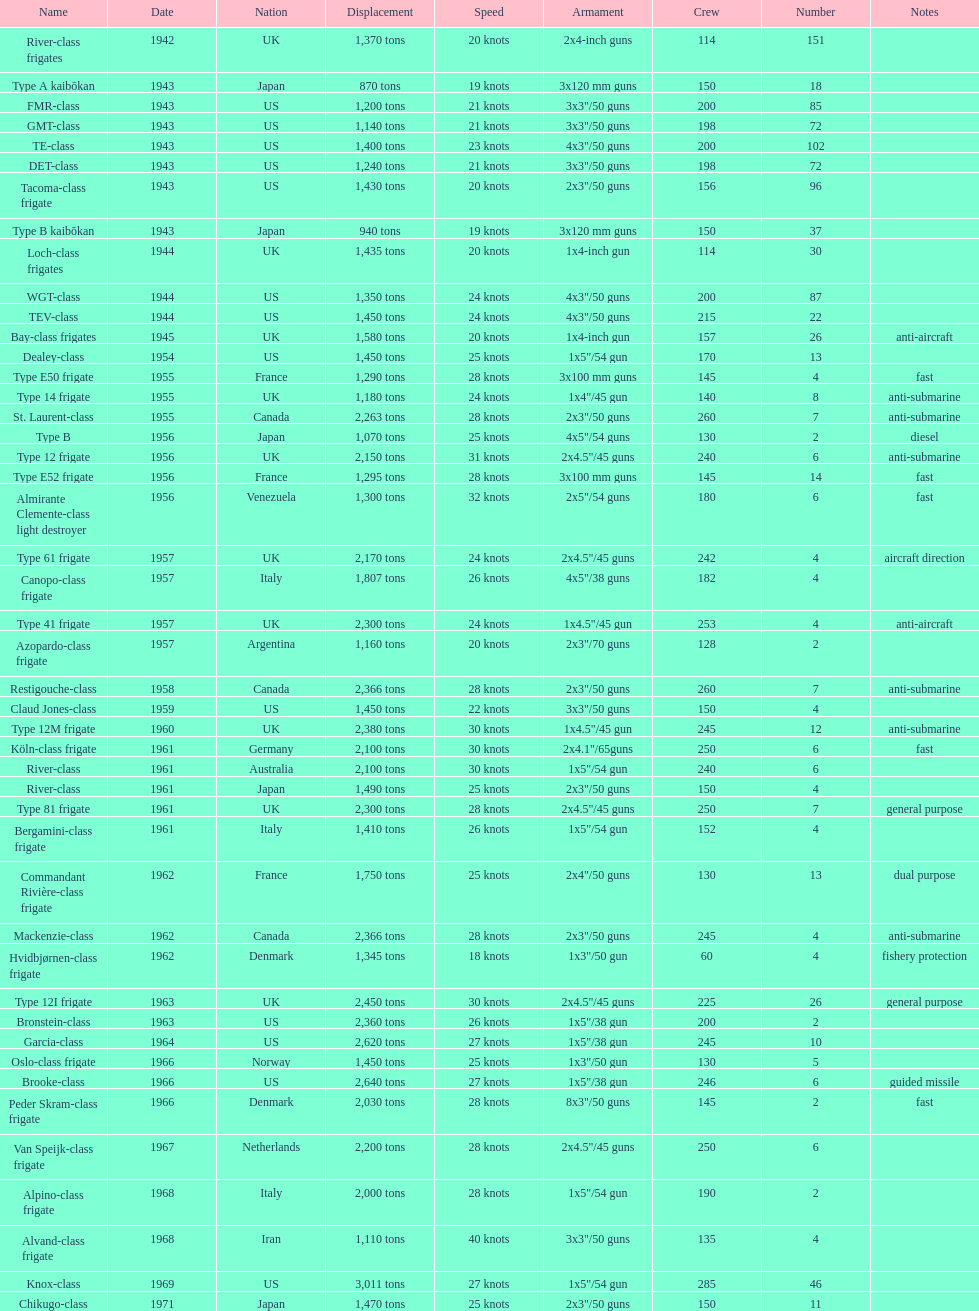How many consecutive escorts were in 1943? 7. 